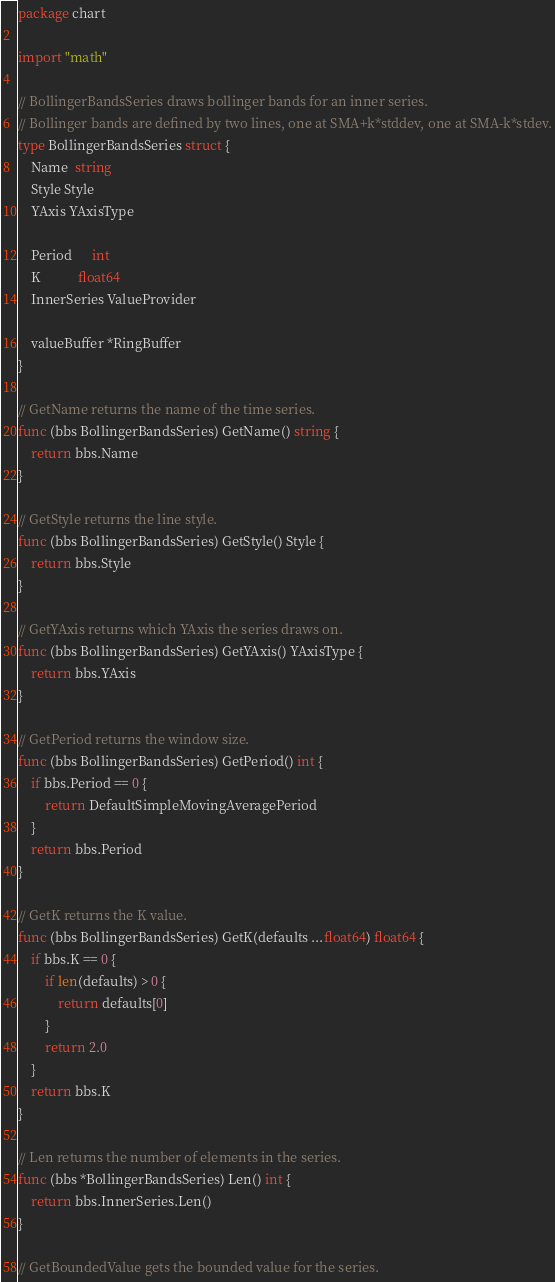Convert code to text. <code><loc_0><loc_0><loc_500><loc_500><_Go_>package chart

import "math"

// BollingerBandsSeries draws bollinger bands for an inner series.
// Bollinger bands are defined by two lines, one at SMA+k*stddev, one at SMA-k*stdev.
type BollingerBandsSeries struct {
	Name  string
	Style Style
	YAxis YAxisType

	Period      int
	K           float64
	InnerSeries ValueProvider

	valueBuffer *RingBuffer
}

// GetName returns the name of the time series.
func (bbs BollingerBandsSeries) GetName() string {
	return bbs.Name
}

// GetStyle returns the line style.
func (bbs BollingerBandsSeries) GetStyle() Style {
	return bbs.Style
}

// GetYAxis returns which YAxis the series draws on.
func (bbs BollingerBandsSeries) GetYAxis() YAxisType {
	return bbs.YAxis
}

// GetPeriod returns the window size.
func (bbs BollingerBandsSeries) GetPeriod() int {
	if bbs.Period == 0 {
		return DefaultSimpleMovingAveragePeriod
	}
	return bbs.Period
}

// GetK returns the K value.
func (bbs BollingerBandsSeries) GetK(defaults ...float64) float64 {
	if bbs.K == 0 {
		if len(defaults) > 0 {
			return defaults[0]
		}
		return 2.0
	}
	return bbs.K
}

// Len returns the number of elements in the series.
func (bbs *BollingerBandsSeries) Len() int {
	return bbs.InnerSeries.Len()
}

// GetBoundedValue gets the bounded value for the series.</code> 